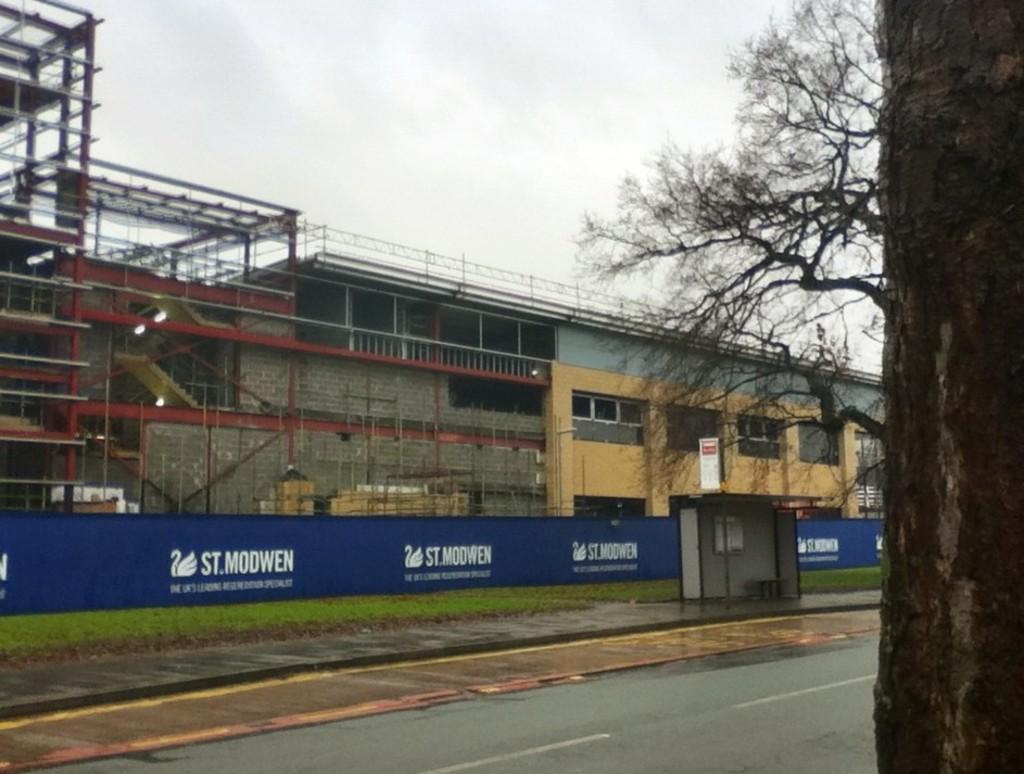How would you summarize this image in a sentence or two? This picture is clicked outside the city. At the bottom of the picture, we see the road. We see a blue color board with some text written on it. Behind that, there are buildings. On the right side, we see a bus stop. On the right corner of the picture, we see a tree. At the top of the picture, we see the sky. 